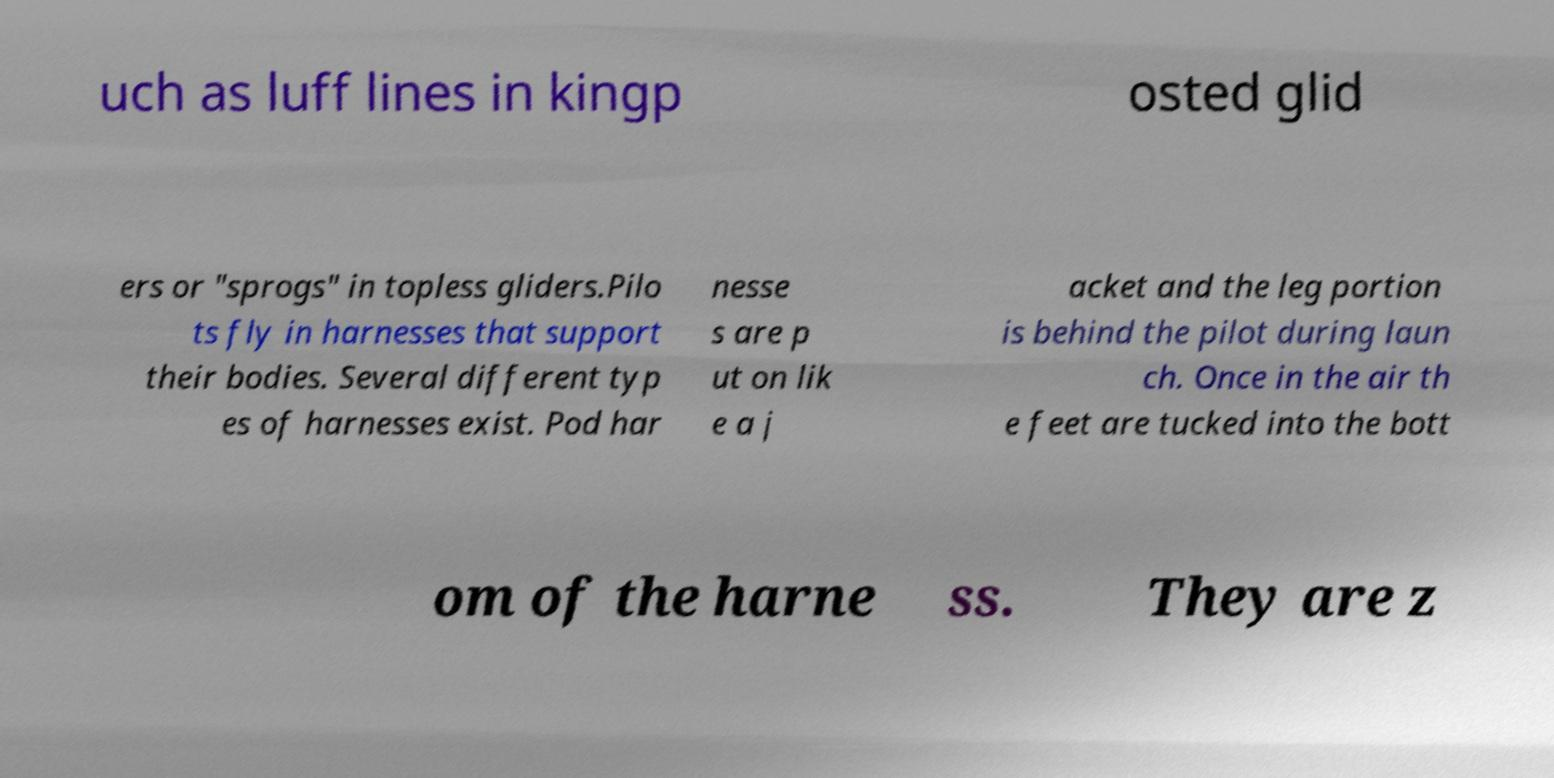Could you extract and type out the text from this image? uch as luff lines in kingp osted glid ers or "sprogs" in topless gliders.Pilo ts fly in harnesses that support their bodies. Several different typ es of harnesses exist. Pod har nesse s are p ut on lik e a j acket and the leg portion is behind the pilot during laun ch. Once in the air th e feet are tucked into the bott om of the harne ss. They are z 